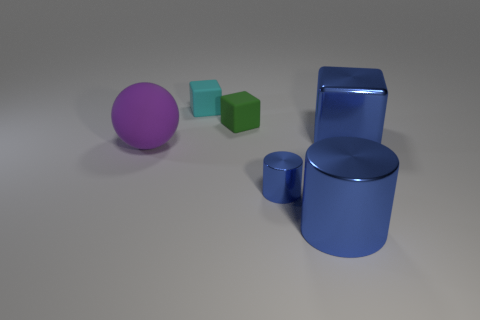Is the big cube the same color as the small cylinder?
Provide a succinct answer. Yes. What is the color of the metal cylinder on the right side of the blue cylinder that is behind the big blue object that is in front of the rubber sphere?
Provide a short and direct response. Blue. What number of other objects are the same color as the metal block?
Offer a very short reply. 2. How many metallic things are either big green balls or blocks?
Your response must be concise. 1. Does the large metallic object that is behind the big matte sphere have the same color as the big metallic thing that is in front of the large cube?
Make the answer very short. Yes. What is the size of the green matte thing that is the same shape as the cyan thing?
Give a very brief answer. Small. Is the number of big objects on the right side of the small blue metallic cylinder greater than the number of big spheres?
Your answer should be very brief. Yes. Does the big object that is left of the tiny cyan thing have the same material as the large blue cylinder?
Your answer should be very brief. No. There is a cyan block left of the metal thing that is to the left of the large blue metallic object that is in front of the big cube; what is its size?
Keep it short and to the point. Small. What size is the purple thing that is the same material as the green object?
Keep it short and to the point. Large. 